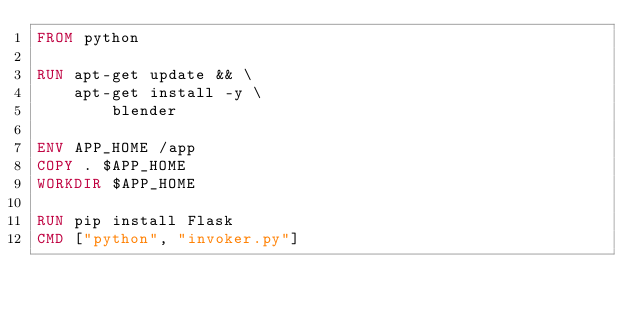<code> <loc_0><loc_0><loc_500><loc_500><_Dockerfile_>FROM python

RUN apt-get update && \
	apt-get install -y \
		blender

ENV APP_HOME /app
COPY . $APP_HOME
WORKDIR $APP_HOME

RUN pip install Flask
CMD ["python", "invoker.py"]</code> 